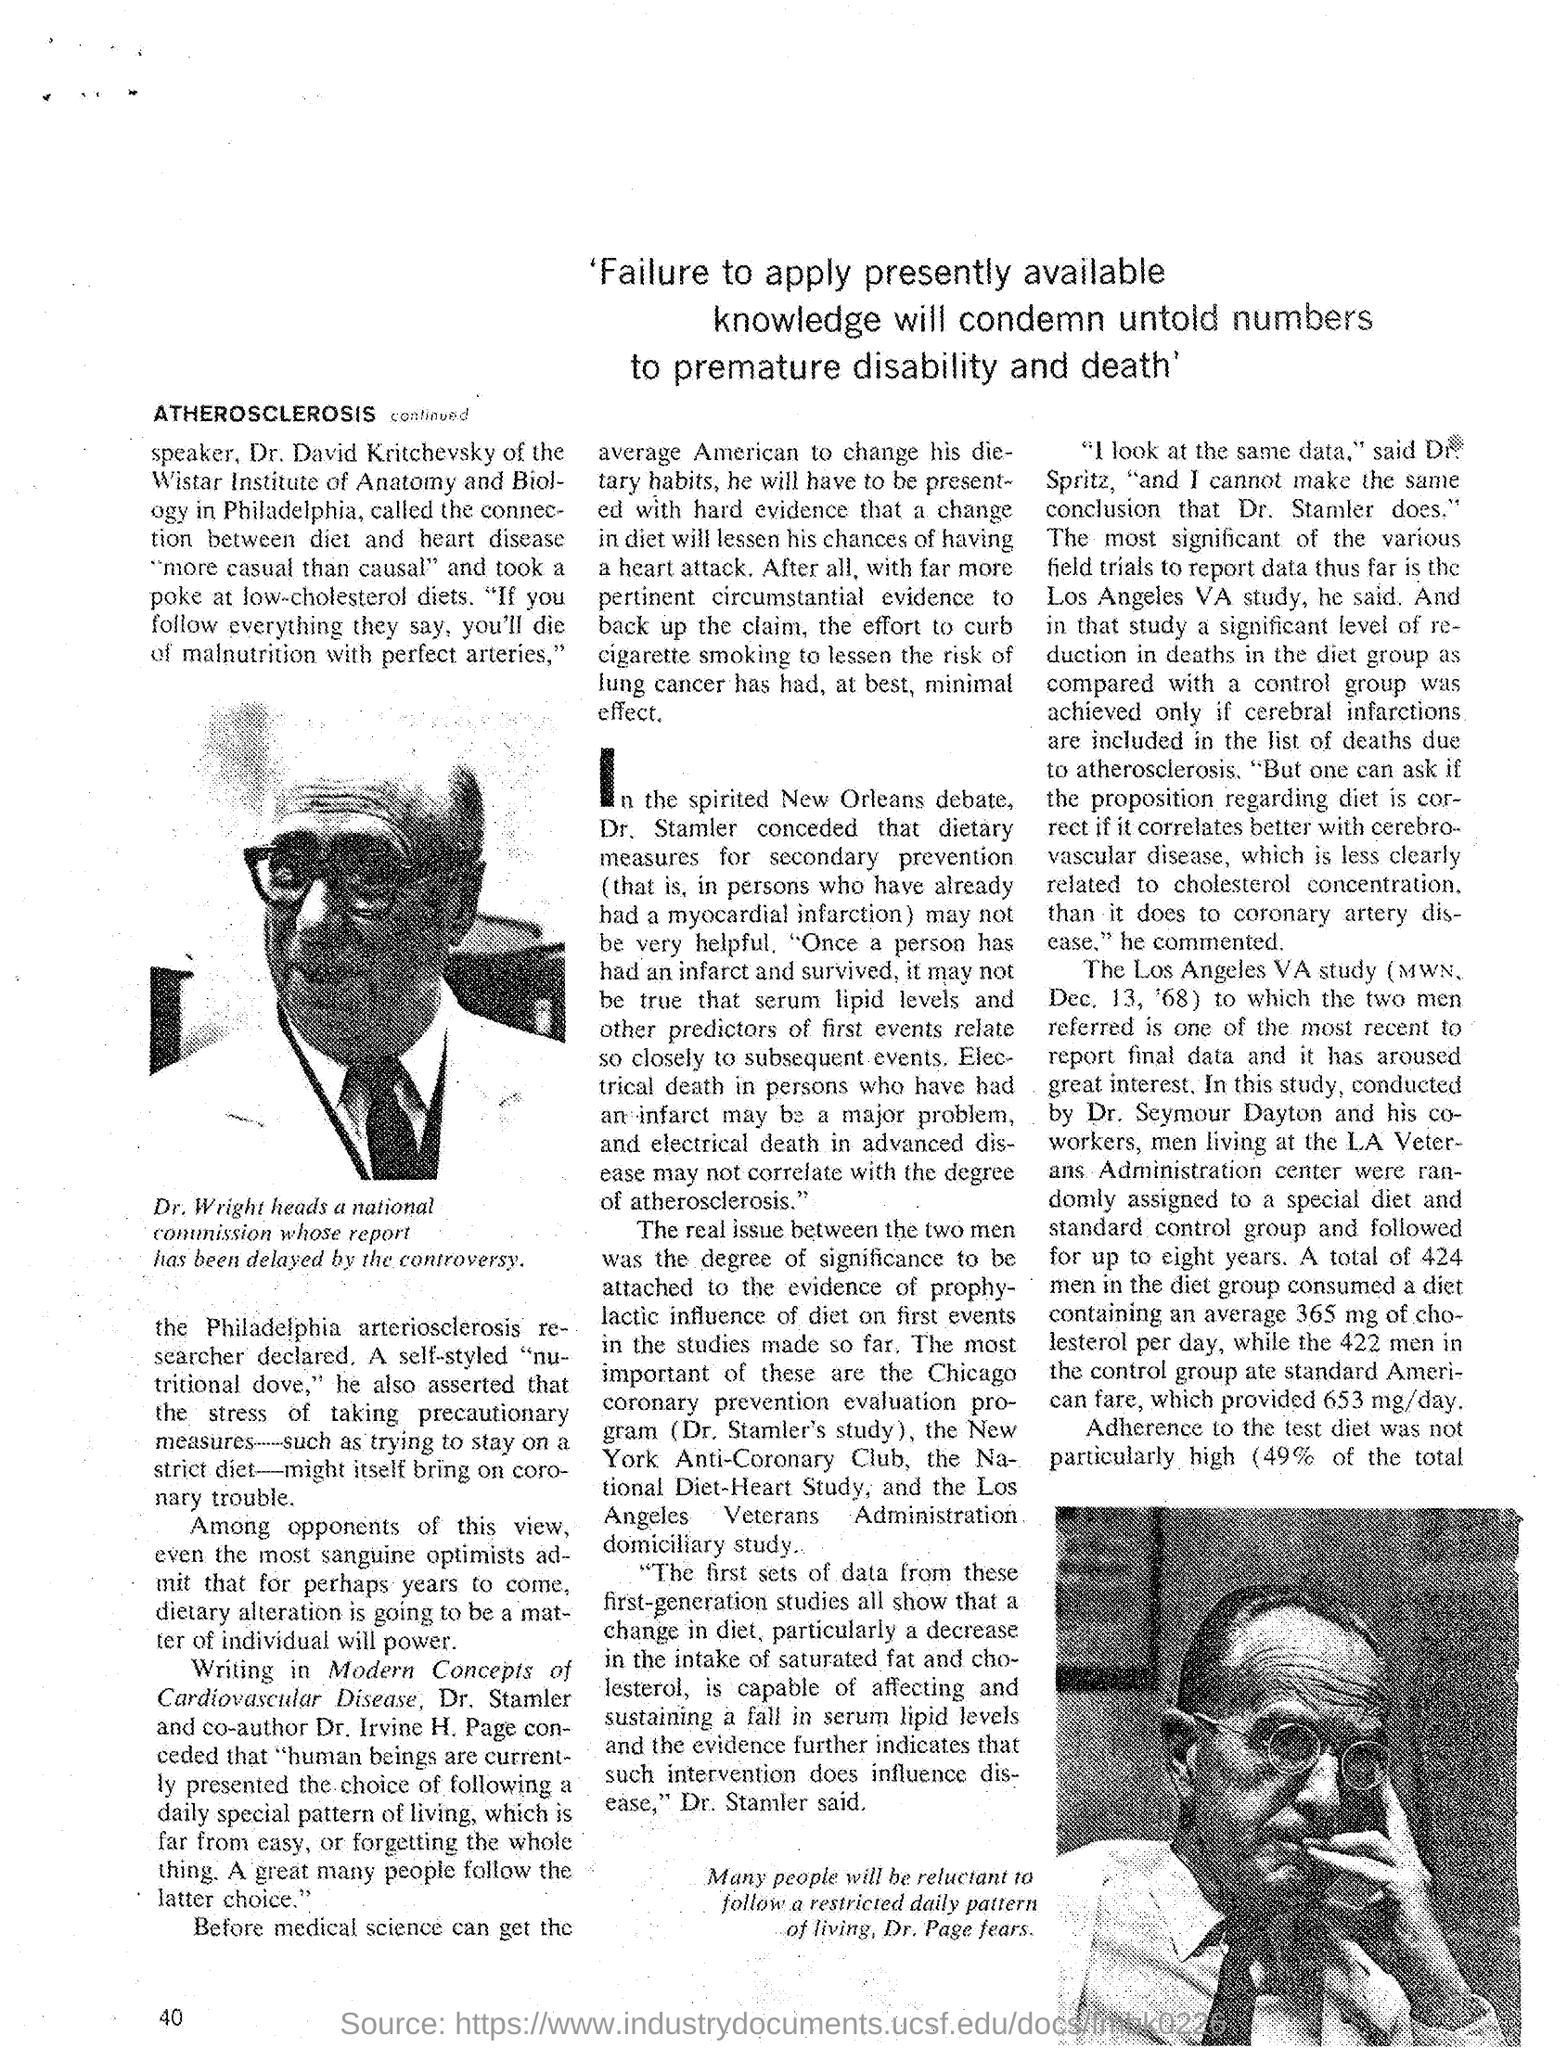Point out several critical features in this image. The Wistar Institute of Anatomy and Biology is located in Philadelphia. 